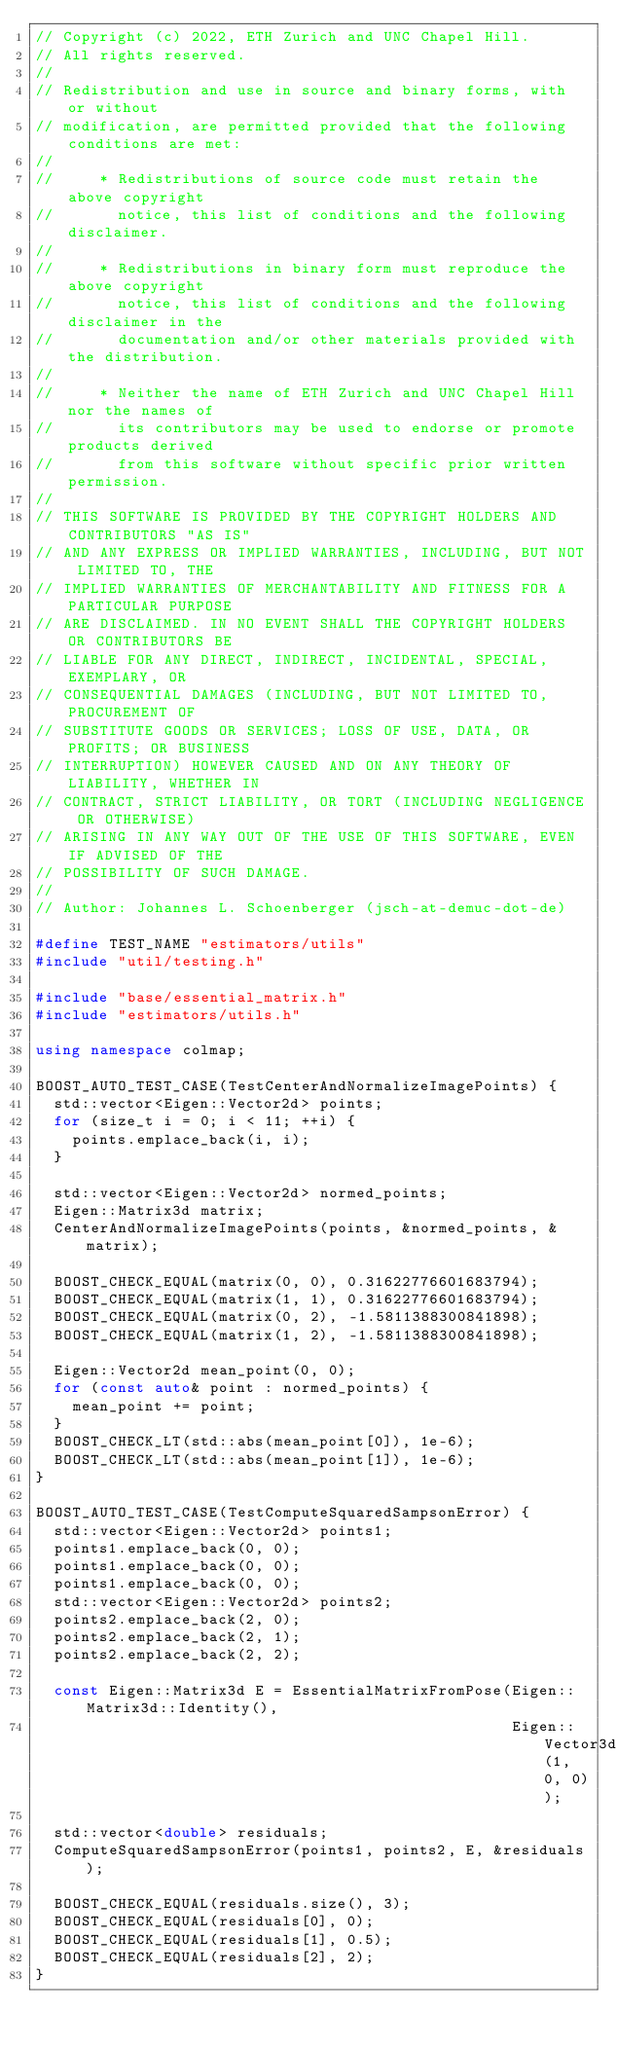Convert code to text. <code><loc_0><loc_0><loc_500><loc_500><_C++_>// Copyright (c) 2022, ETH Zurich and UNC Chapel Hill.
// All rights reserved.
//
// Redistribution and use in source and binary forms, with or without
// modification, are permitted provided that the following conditions are met:
//
//     * Redistributions of source code must retain the above copyright
//       notice, this list of conditions and the following disclaimer.
//
//     * Redistributions in binary form must reproduce the above copyright
//       notice, this list of conditions and the following disclaimer in the
//       documentation and/or other materials provided with the distribution.
//
//     * Neither the name of ETH Zurich and UNC Chapel Hill nor the names of
//       its contributors may be used to endorse or promote products derived
//       from this software without specific prior written permission.
//
// THIS SOFTWARE IS PROVIDED BY THE COPYRIGHT HOLDERS AND CONTRIBUTORS "AS IS"
// AND ANY EXPRESS OR IMPLIED WARRANTIES, INCLUDING, BUT NOT LIMITED TO, THE
// IMPLIED WARRANTIES OF MERCHANTABILITY AND FITNESS FOR A PARTICULAR PURPOSE
// ARE DISCLAIMED. IN NO EVENT SHALL THE COPYRIGHT HOLDERS OR CONTRIBUTORS BE
// LIABLE FOR ANY DIRECT, INDIRECT, INCIDENTAL, SPECIAL, EXEMPLARY, OR
// CONSEQUENTIAL DAMAGES (INCLUDING, BUT NOT LIMITED TO, PROCUREMENT OF
// SUBSTITUTE GOODS OR SERVICES; LOSS OF USE, DATA, OR PROFITS; OR BUSINESS
// INTERRUPTION) HOWEVER CAUSED AND ON ANY THEORY OF LIABILITY, WHETHER IN
// CONTRACT, STRICT LIABILITY, OR TORT (INCLUDING NEGLIGENCE OR OTHERWISE)
// ARISING IN ANY WAY OUT OF THE USE OF THIS SOFTWARE, EVEN IF ADVISED OF THE
// POSSIBILITY OF SUCH DAMAGE.
//
// Author: Johannes L. Schoenberger (jsch-at-demuc-dot-de)

#define TEST_NAME "estimators/utils"
#include "util/testing.h"

#include "base/essential_matrix.h"
#include "estimators/utils.h"

using namespace colmap;

BOOST_AUTO_TEST_CASE(TestCenterAndNormalizeImagePoints) {
  std::vector<Eigen::Vector2d> points;
  for (size_t i = 0; i < 11; ++i) {
    points.emplace_back(i, i);
  }

  std::vector<Eigen::Vector2d> normed_points;
  Eigen::Matrix3d matrix;
  CenterAndNormalizeImagePoints(points, &normed_points, &matrix);

  BOOST_CHECK_EQUAL(matrix(0, 0), 0.31622776601683794);
  BOOST_CHECK_EQUAL(matrix(1, 1), 0.31622776601683794);
  BOOST_CHECK_EQUAL(matrix(0, 2), -1.5811388300841898);
  BOOST_CHECK_EQUAL(matrix(1, 2), -1.5811388300841898);

  Eigen::Vector2d mean_point(0, 0);
  for (const auto& point : normed_points) {
    mean_point += point;
  }
  BOOST_CHECK_LT(std::abs(mean_point[0]), 1e-6);
  BOOST_CHECK_LT(std::abs(mean_point[1]), 1e-6);
}

BOOST_AUTO_TEST_CASE(TestComputeSquaredSampsonError) {
  std::vector<Eigen::Vector2d> points1;
  points1.emplace_back(0, 0);
  points1.emplace_back(0, 0);
  points1.emplace_back(0, 0);
  std::vector<Eigen::Vector2d> points2;
  points2.emplace_back(2, 0);
  points2.emplace_back(2, 1);
  points2.emplace_back(2, 2);

  const Eigen::Matrix3d E = EssentialMatrixFromPose(Eigen::Matrix3d::Identity(),
                                                    Eigen::Vector3d(1, 0, 0));

  std::vector<double> residuals;
  ComputeSquaredSampsonError(points1, points2, E, &residuals);

  BOOST_CHECK_EQUAL(residuals.size(), 3);
  BOOST_CHECK_EQUAL(residuals[0], 0);
  BOOST_CHECK_EQUAL(residuals[1], 0.5);
  BOOST_CHECK_EQUAL(residuals[2], 2);
}
</code> 